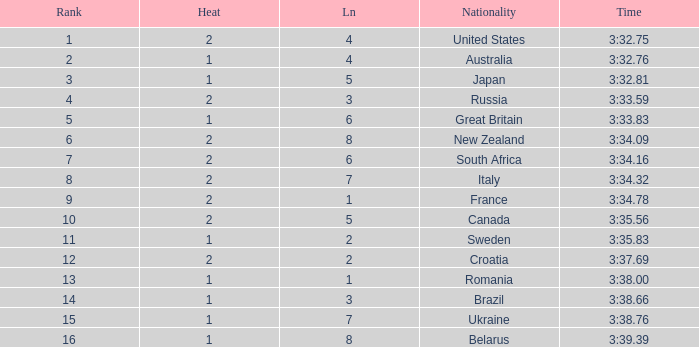Can you tell me the Rank that has the Lane of 6, and the Heat of 2? 7.0. 